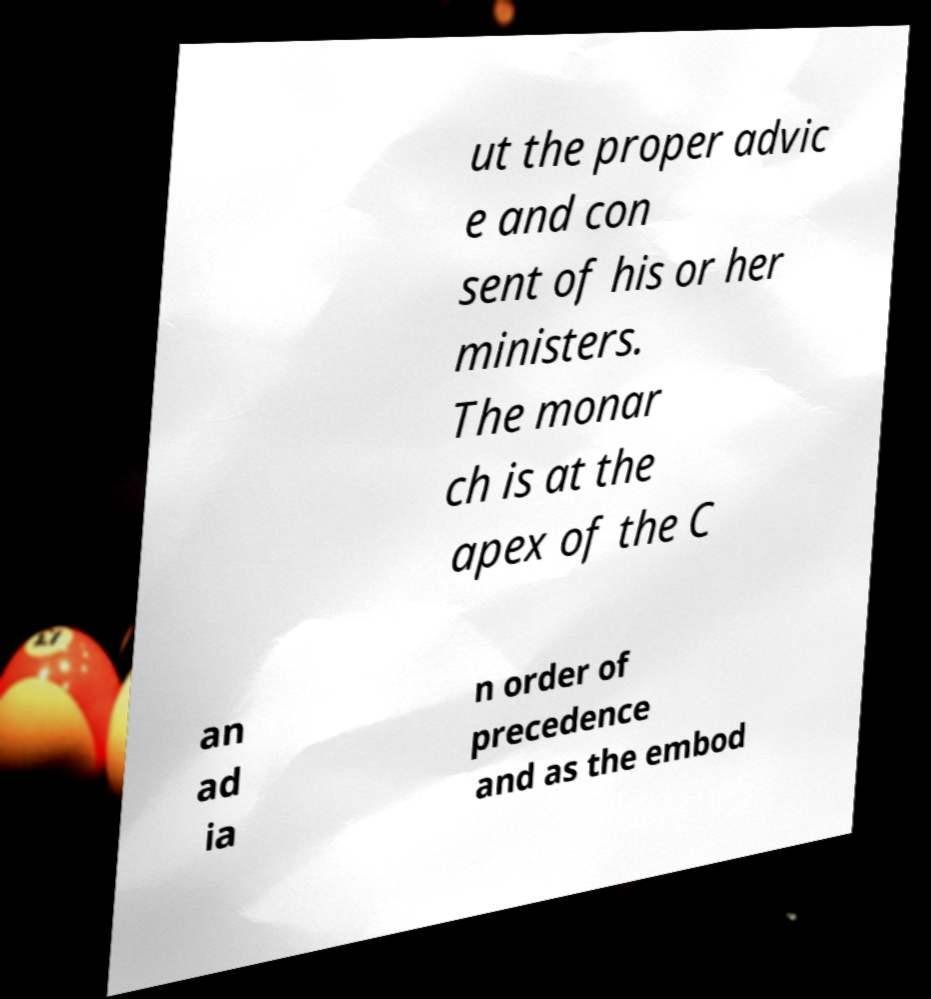Can you read and provide the text displayed in the image?This photo seems to have some interesting text. Can you extract and type it out for me? ut the proper advic e and con sent of his or her ministers. The monar ch is at the apex of the C an ad ia n order of precedence and as the embod 